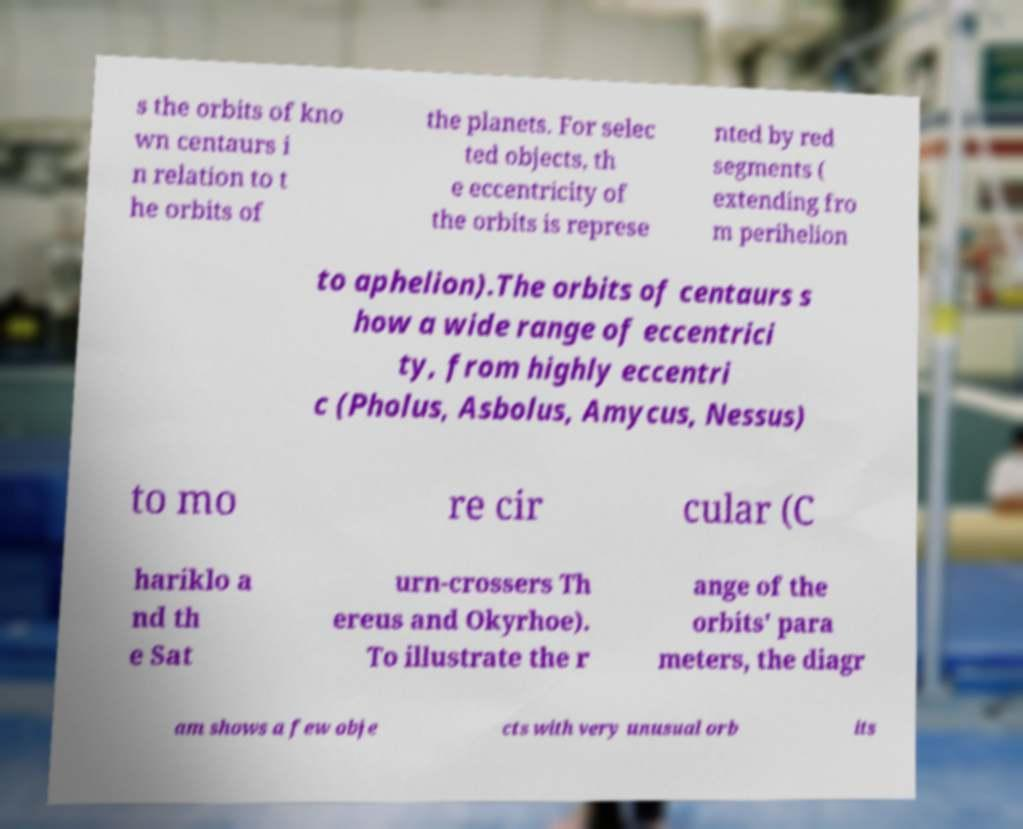I need the written content from this picture converted into text. Can you do that? s the orbits of kno wn centaurs i n relation to t he orbits of the planets. For selec ted objects, th e eccentricity of the orbits is represe nted by red segments ( extending fro m perihelion to aphelion).The orbits of centaurs s how a wide range of eccentrici ty, from highly eccentri c (Pholus, Asbolus, Amycus, Nessus) to mo re cir cular (C hariklo a nd th e Sat urn-crossers Th ereus and Okyrhoe). To illustrate the r ange of the orbits' para meters, the diagr am shows a few obje cts with very unusual orb its 